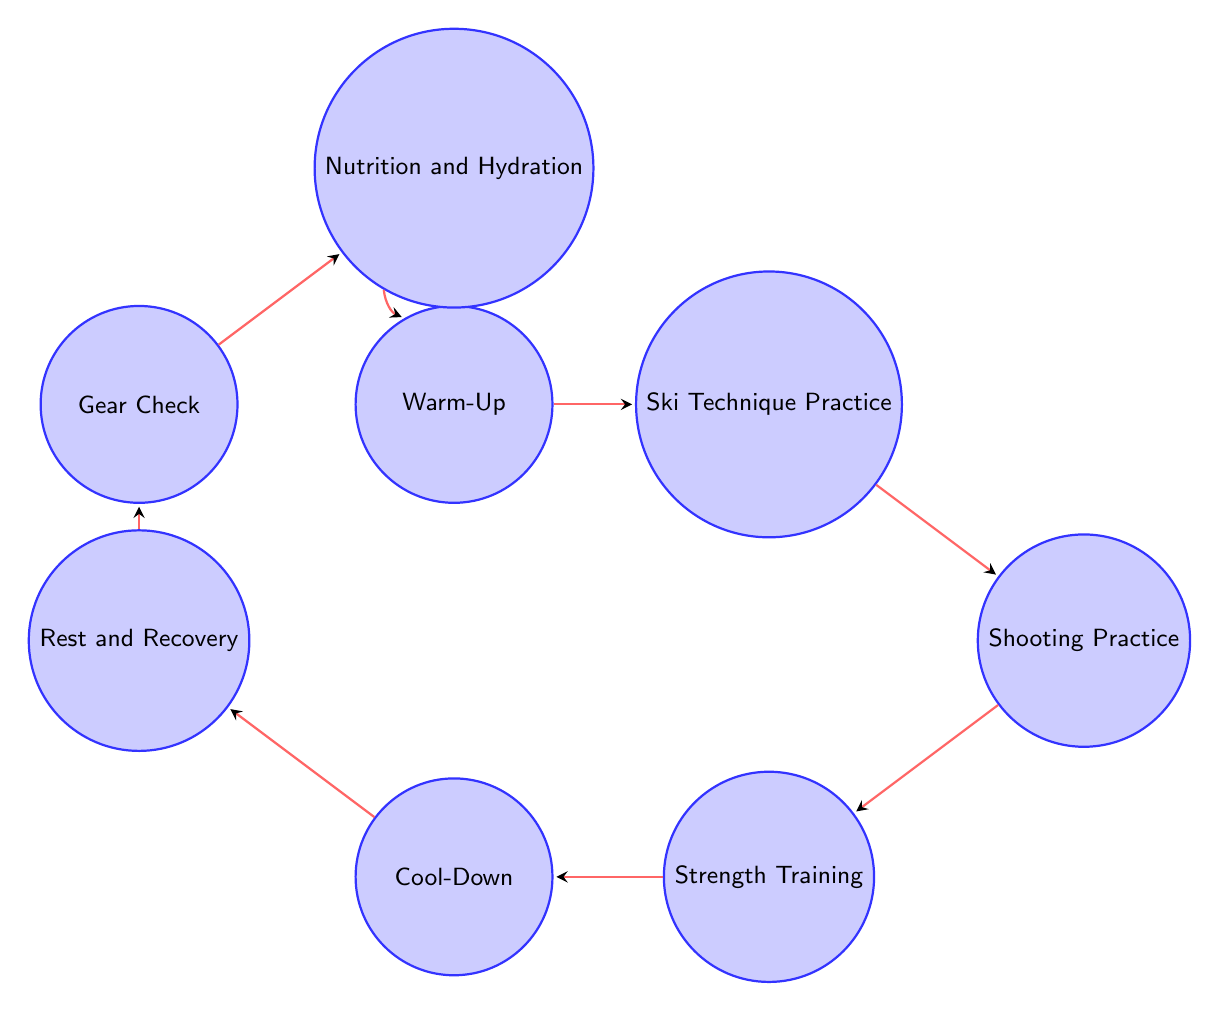What is the first state in the diagram? The first state in the diagram, as indicated by the arrows and starting point, is "Warm-Up."
Answer: Warm-Up How many states are there in total in this diagram? By counting each individual node, there are a total of eight states represented in the diagram.
Answer: 8 What state comes immediately after "Strength Training"? The state that immediately follows "Strength Training," according to the directed edges, is "Cool-Down."
Answer: Cool-Down What state leads to "Nutrition and Hydration"? The state that transitions to "Nutrition and Hydration" is "Gear Check," as represented by the arrow directing from "Gear Check" to "Nutrition and Hydration."
Answer: Gear Check Which state is the last in the transition sequence before returning to "Warm-Up"? The last state before returning to "Warm-Up" is "Nutrition and Hydration," which connects back to "Warm-Up."
Answer: Nutrition and Hydration If you start from "Shooting Practice," what is the next state you will reach? After "Shooting Practice," the next state in the flow is "Strength Training," following the directional edge leading from "Shooting Practice" to "Strength Training."
Answer: Strength Training What is the relationship between "Cool-Down" and "Rest and Recovery"? "Cool-Down" leads to "Rest and Recovery," as indicated by the directed edge going from "Cool-Down" to "Rest and Recovery."
Answer: Leads to Which state represents an important step for muscle recovery? "Cool-Down" represents an important step for muscle recovery, as it focuses on static stretching and aids in muscle recovery.
Answer: Cool-Down 